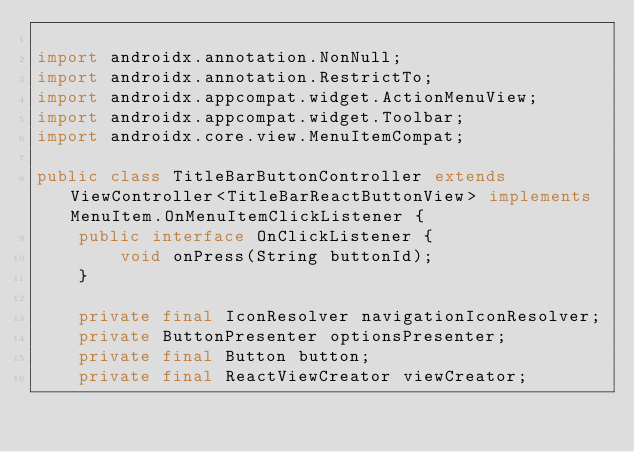<code> <loc_0><loc_0><loc_500><loc_500><_Java_>
import androidx.annotation.NonNull;
import androidx.annotation.RestrictTo;
import androidx.appcompat.widget.ActionMenuView;
import androidx.appcompat.widget.Toolbar;
import androidx.core.view.MenuItemCompat;

public class TitleBarButtonController extends ViewController<TitleBarReactButtonView> implements MenuItem.OnMenuItemClickListener {
    public interface OnClickListener {
        void onPress(String buttonId);
    }

    private final IconResolver navigationIconResolver;
    private ButtonPresenter optionsPresenter;
    private final Button button;
    private final ReactViewCreator viewCreator;</code> 